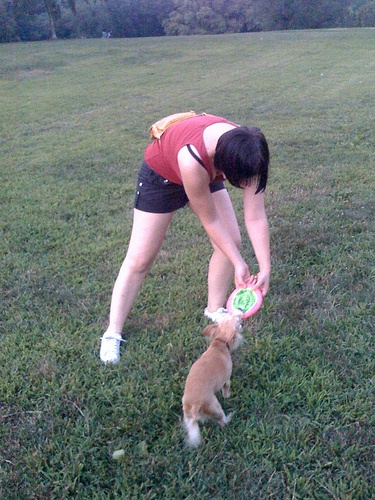Describe the objects in this image and their specific colors. I can see people in gray, lavender, lightpink, black, and pink tones, dog in gray, darkgray, and lightpink tones, frisbee in gray, white, violet, lightgreen, and aquamarine tones, and handbag in gray, white, lightpink, brown, and darkgray tones in this image. 